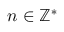Convert formula to latex. <formula><loc_0><loc_0><loc_500><loc_500>n \in \mathbb { Z ^ { \ast } }</formula> 